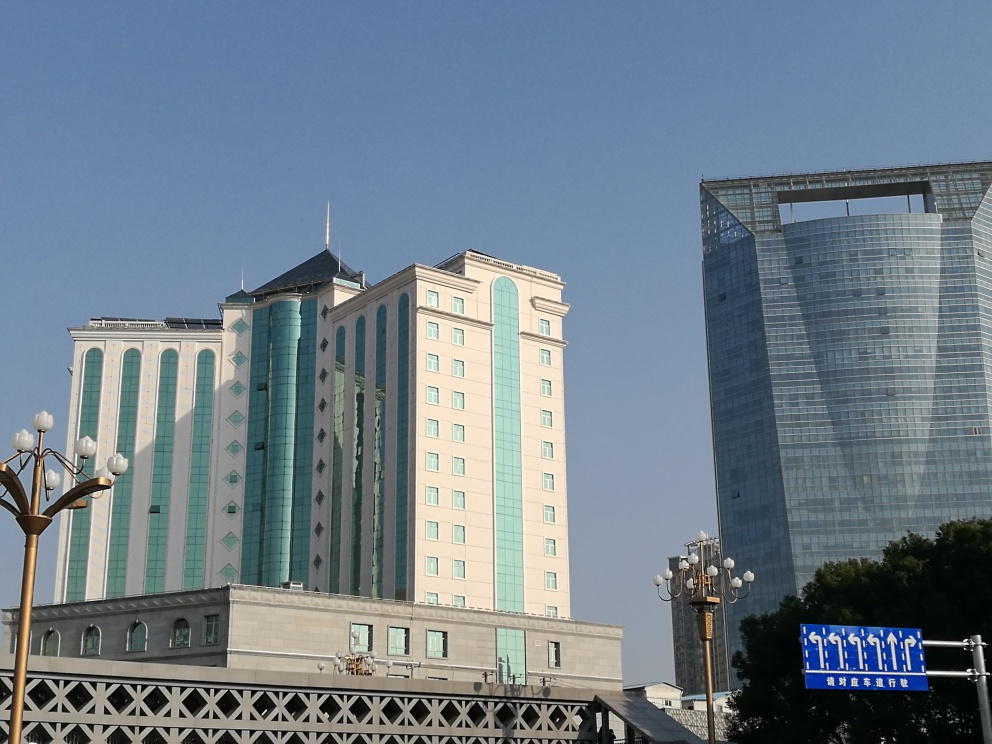What does the signage in the image indicate about the location? The signage, visible in the lower right corner of the image, contains characters that suggest the location could be in a region where the script is used, potentially in China. It appears to be blue with white characters, consistent with informational signage, possibly indicating directions or the name of the place. 